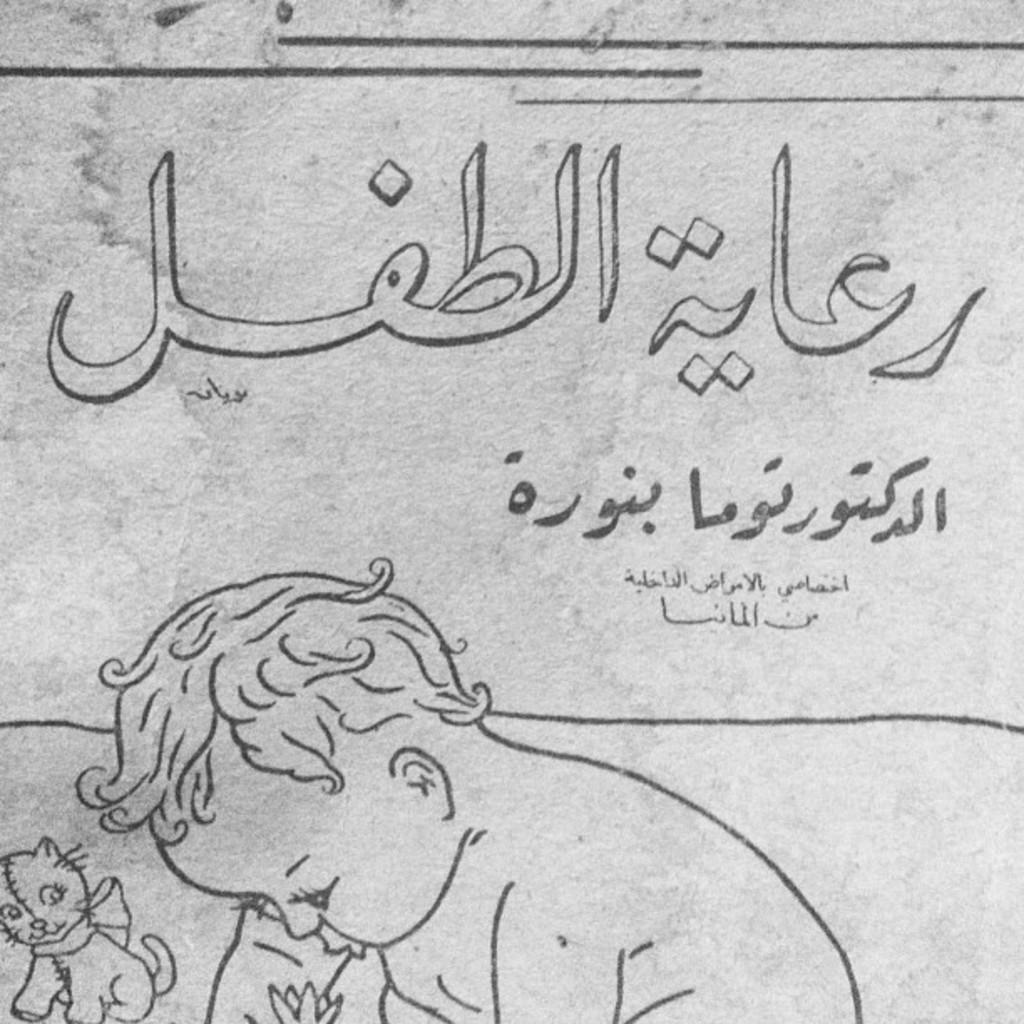What type of art is shown in the image? The image appears to be a pencil art. Who or what is depicted in the art? The art depicts a small boy and a cat. What language are the letters written in? The letters in the image are written in the Urdu language. What type of collar is the cat wearing in the image? There is no collar visible on the cat in the image. How many pies are present in the image? There are no pies present in the image. 